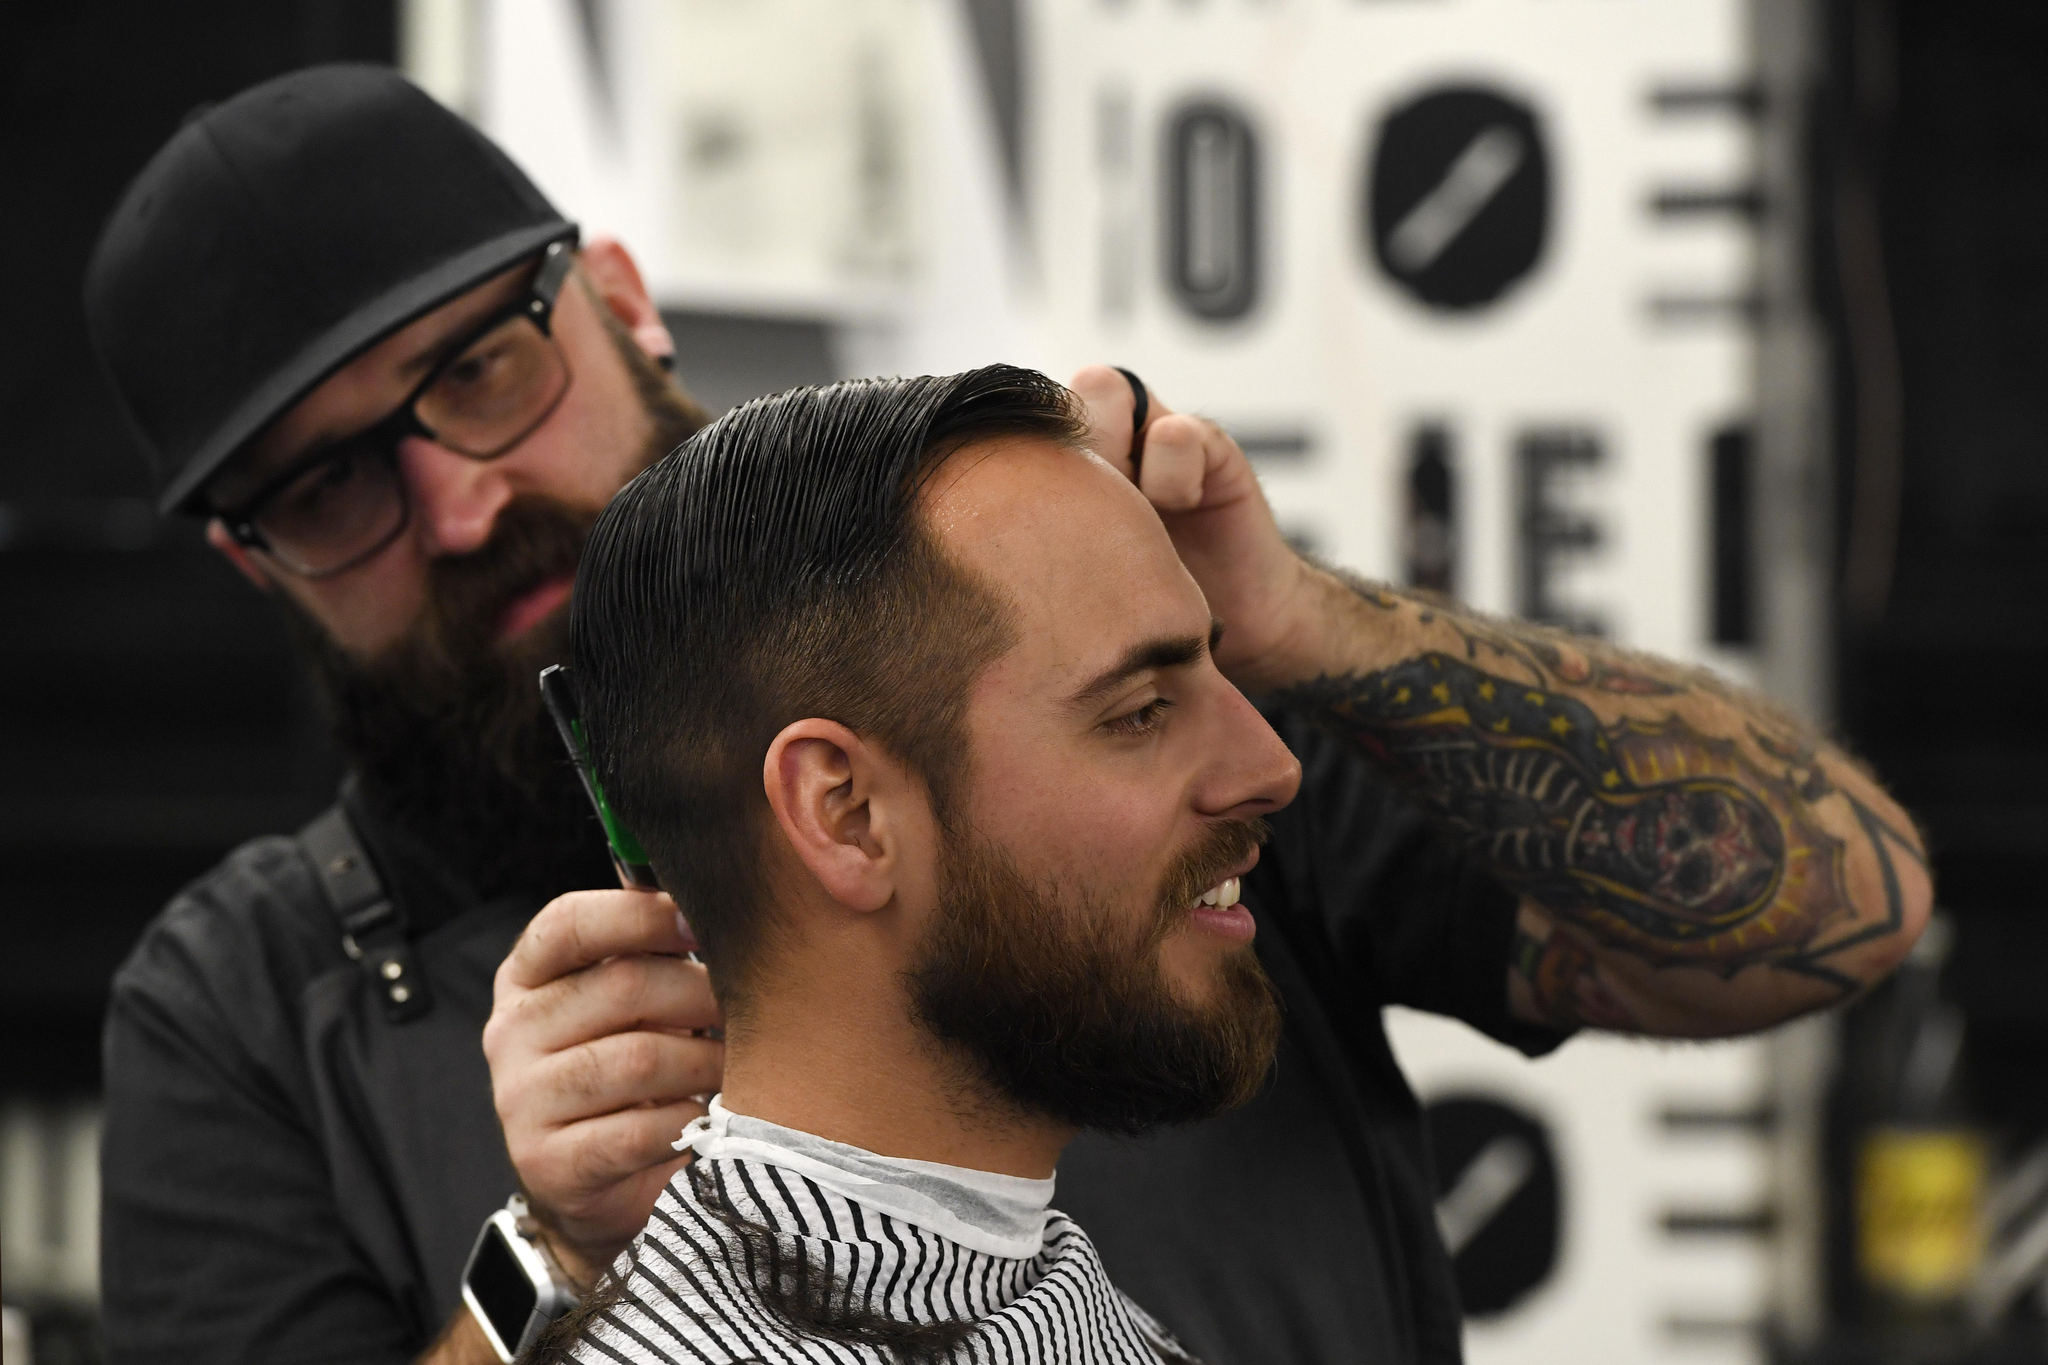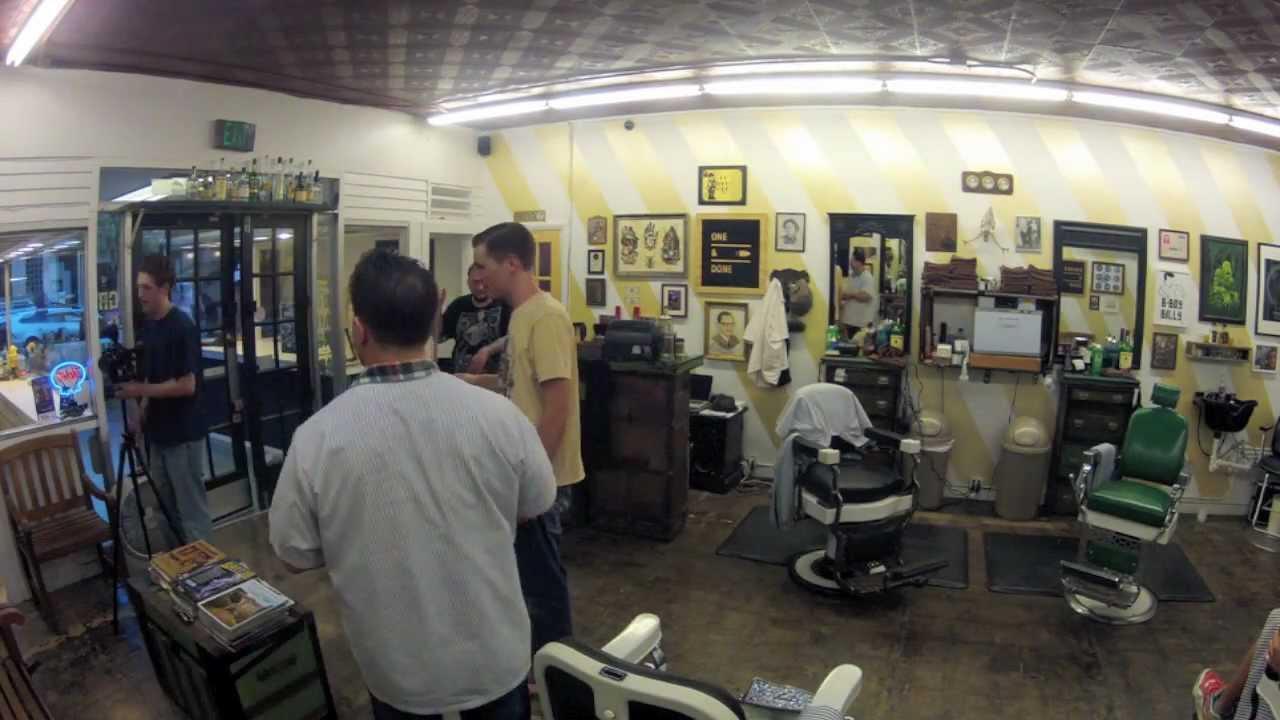The first image is the image on the left, the second image is the image on the right. Considering the images on both sides, is "IN at least one image there are two men in a row getting their cut." valid? Answer yes or no. No. The first image is the image on the left, the second image is the image on the right. Assess this claim about the two images: "Someone is wearing a hat in both images.". Correct or not? Answer yes or no. No. 